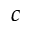<formula> <loc_0><loc_0><loc_500><loc_500>c</formula> 